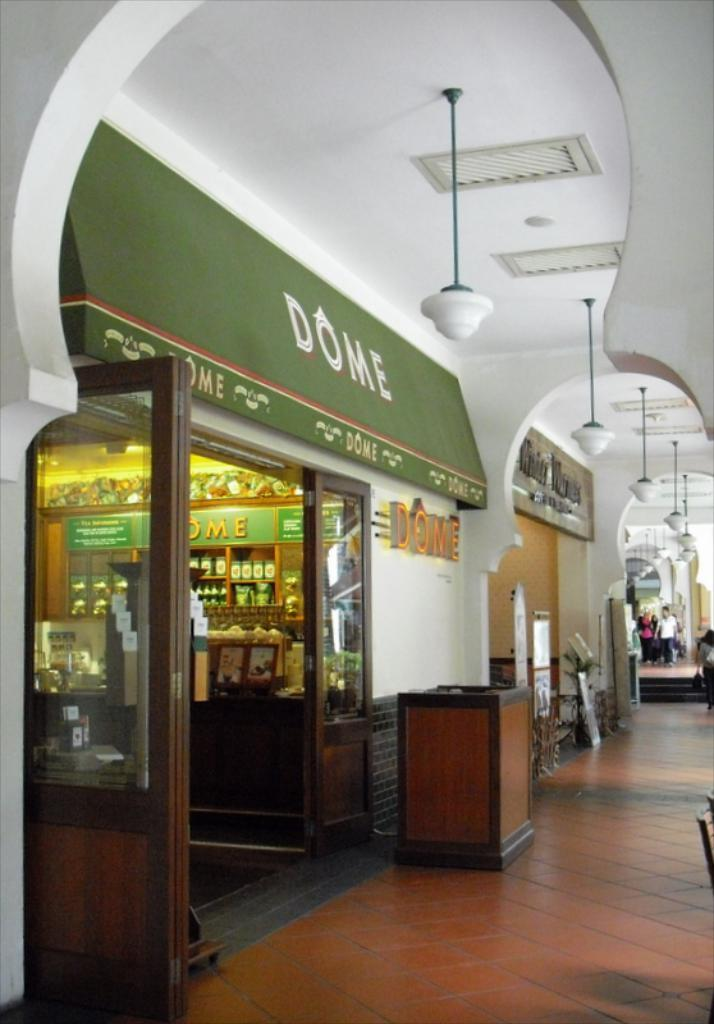<image>
Create a compact narrative representing the image presented. Dome Cafe with a green awning and different types of products on shelves. 